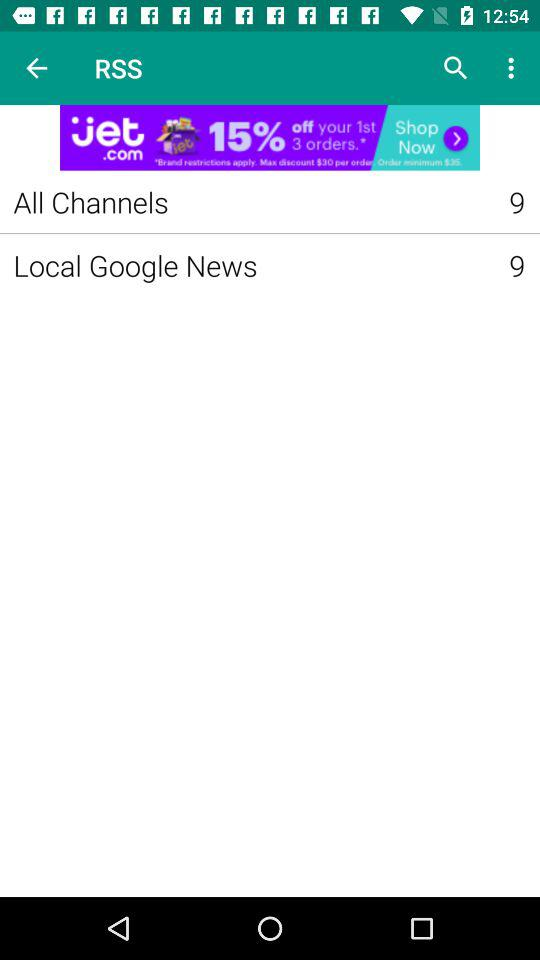How many "Local Google News" are in RSS? There are 9 "Local Google News" in RSS. 